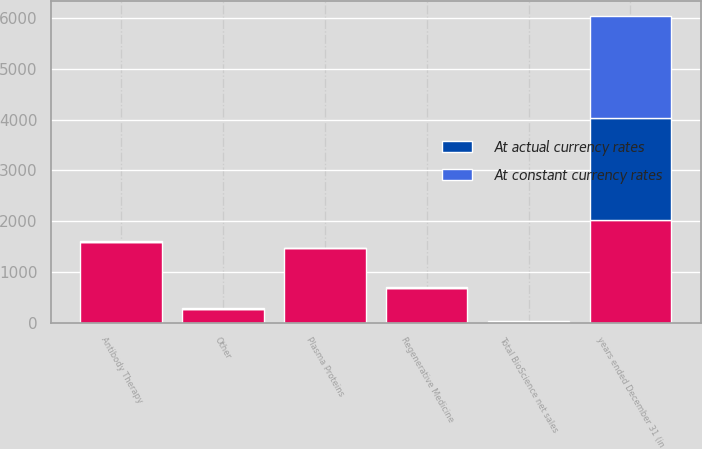Convert chart. <chart><loc_0><loc_0><loc_500><loc_500><stacked_bar_chart><ecel><fcel>years ended December 31 (in<fcel>Antibody Therapy<fcel>Plasma Proteins<fcel>Regenerative Medicine<fcel>Other<fcel>Total BioScience net sales<nl><fcel>nan<fcel>2012<fcel>1593<fcel>1464<fcel>673<fcel>273<fcel>16<nl><fcel>At actual currency rates<fcel>2012<fcel>3<fcel>2<fcel>16<fcel>3<fcel>3<nl><fcel>At constant currency rates<fcel>2012<fcel>5<fcel>4<fcel>19<fcel>5<fcel>6<nl></chart> 